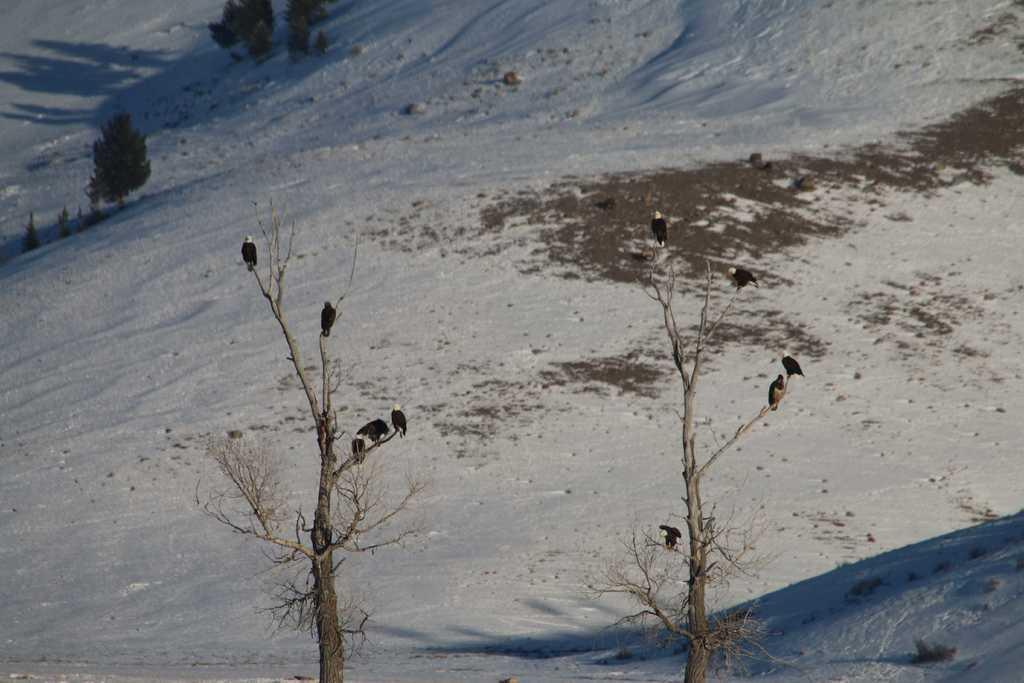What type of vegetation can be seen in the image? There are trees and plants visible in the image. How are the trees in the image? The trees appear to be truncated. What can be seen in the trees? There are birds in the trees. What is the weather like in the image? There is snow visible in the image, suggesting a cold or wintry environment. How many dogs can be seen playing in the basin in the image? There are no dogs or basins present in the image. What type of beetle can be seen crawling on the plants in the image? There are no beetles visible in the image; only trees, plants, and birds are present. 